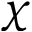Convert formula to latex. <formula><loc_0><loc_0><loc_500><loc_500>\chi</formula> 